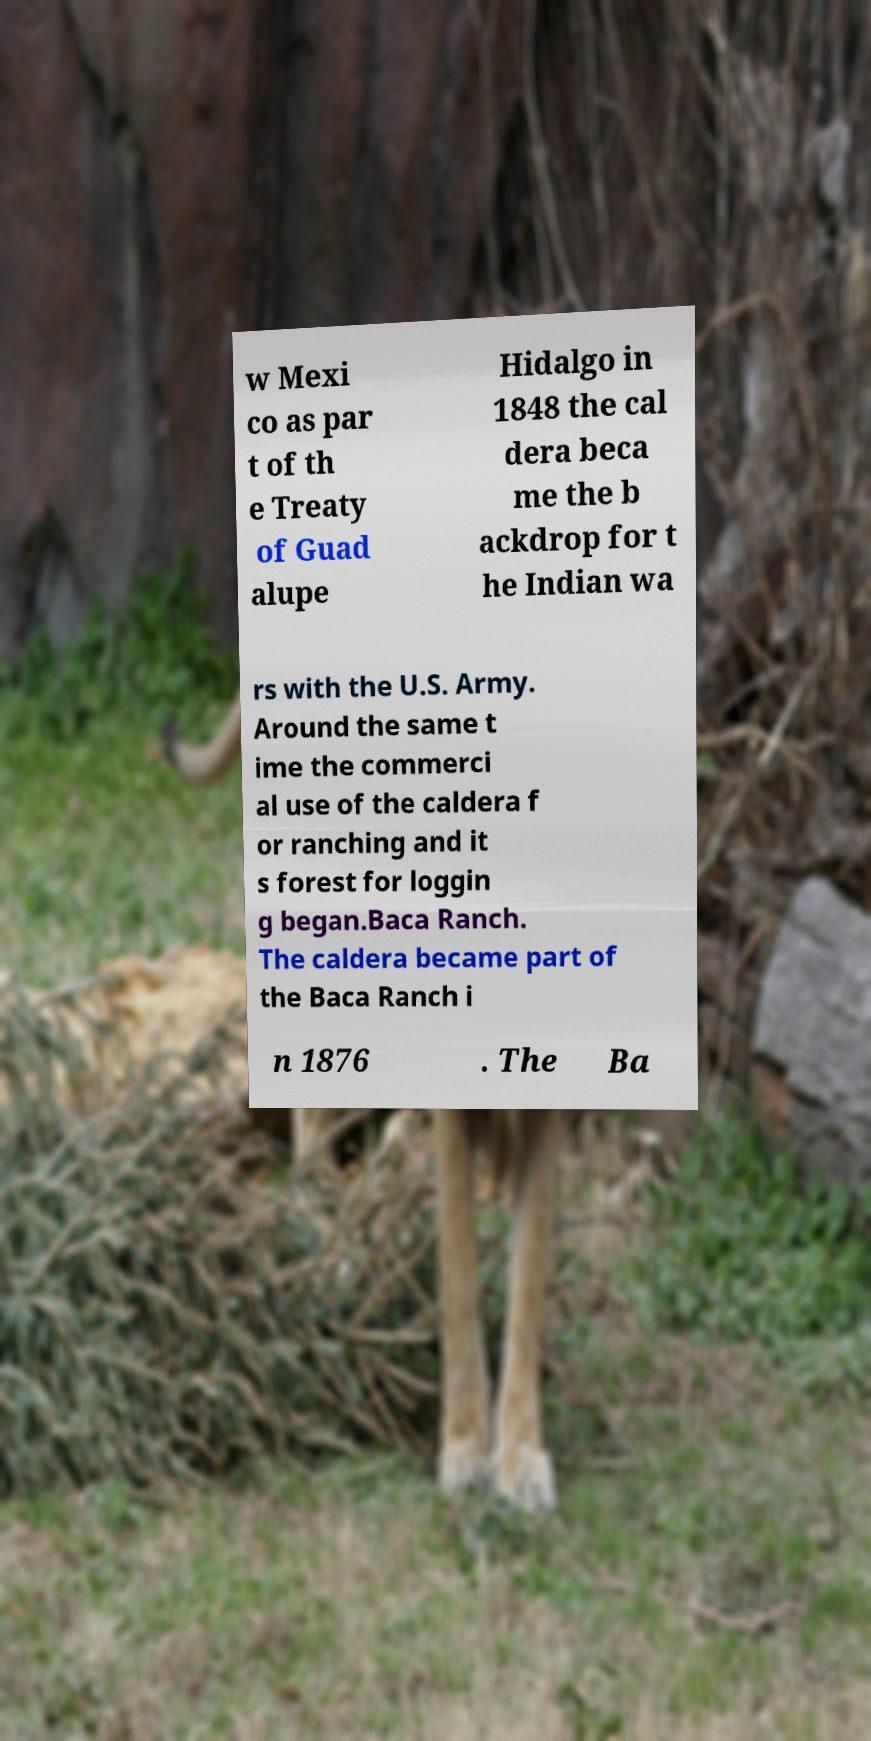Please read and relay the text visible in this image. What does it say? w Mexi co as par t of th e Treaty of Guad alupe Hidalgo in 1848 the cal dera beca me the b ackdrop for t he Indian wa rs with the U.S. Army. Around the same t ime the commerci al use of the caldera f or ranching and it s forest for loggin g began.Baca Ranch. The caldera became part of the Baca Ranch i n 1876 . The Ba 